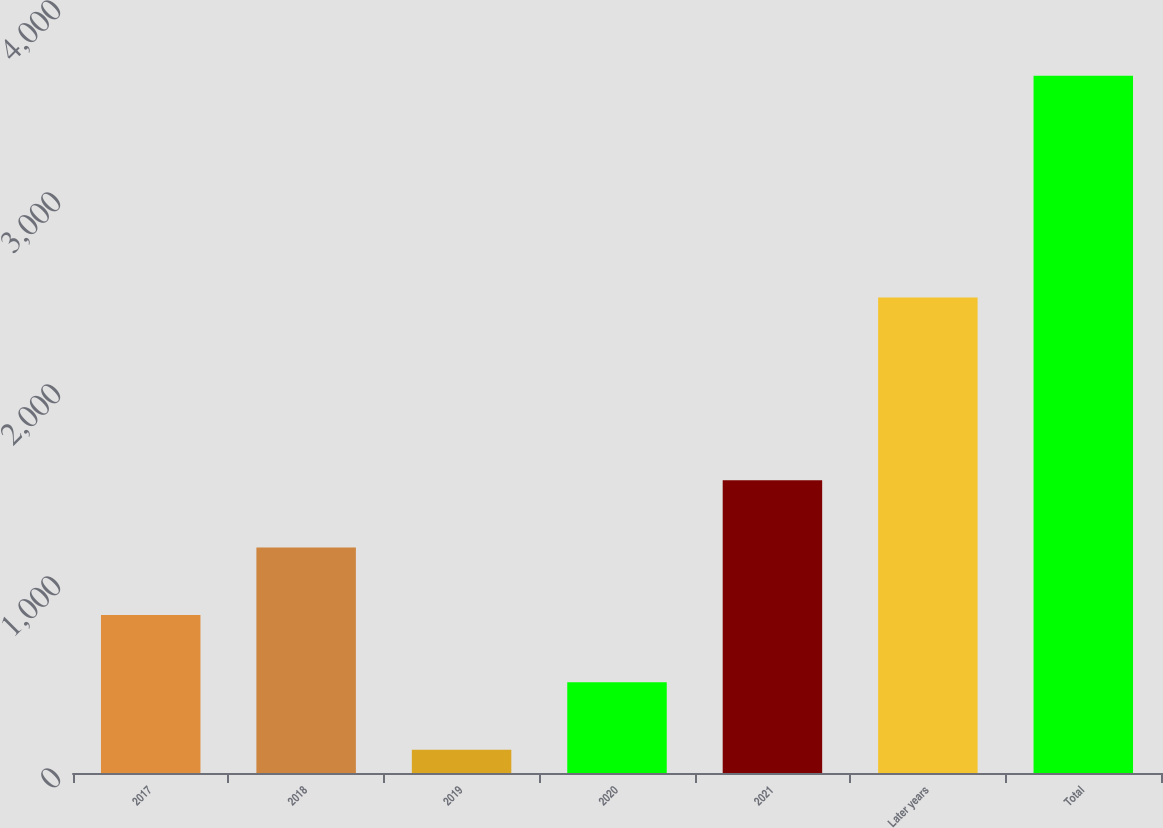Convert chart. <chart><loc_0><loc_0><loc_500><loc_500><bar_chart><fcel>2017<fcel>2018<fcel>2019<fcel>2020<fcel>2021<fcel>Later years<fcel>Total<nl><fcel>823.08<fcel>1174.07<fcel>121.1<fcel>472.09<fcel>1525.06<fcel>2476.2<fcel>3631<nl></chart> 